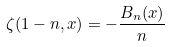Convert formula to latex. <formula><loc_0><loc_0><loc_500><loc_500>\zeta ( 1 - n , x ) = - \frac { B _ { n } ( x ) } { n }</formula> 